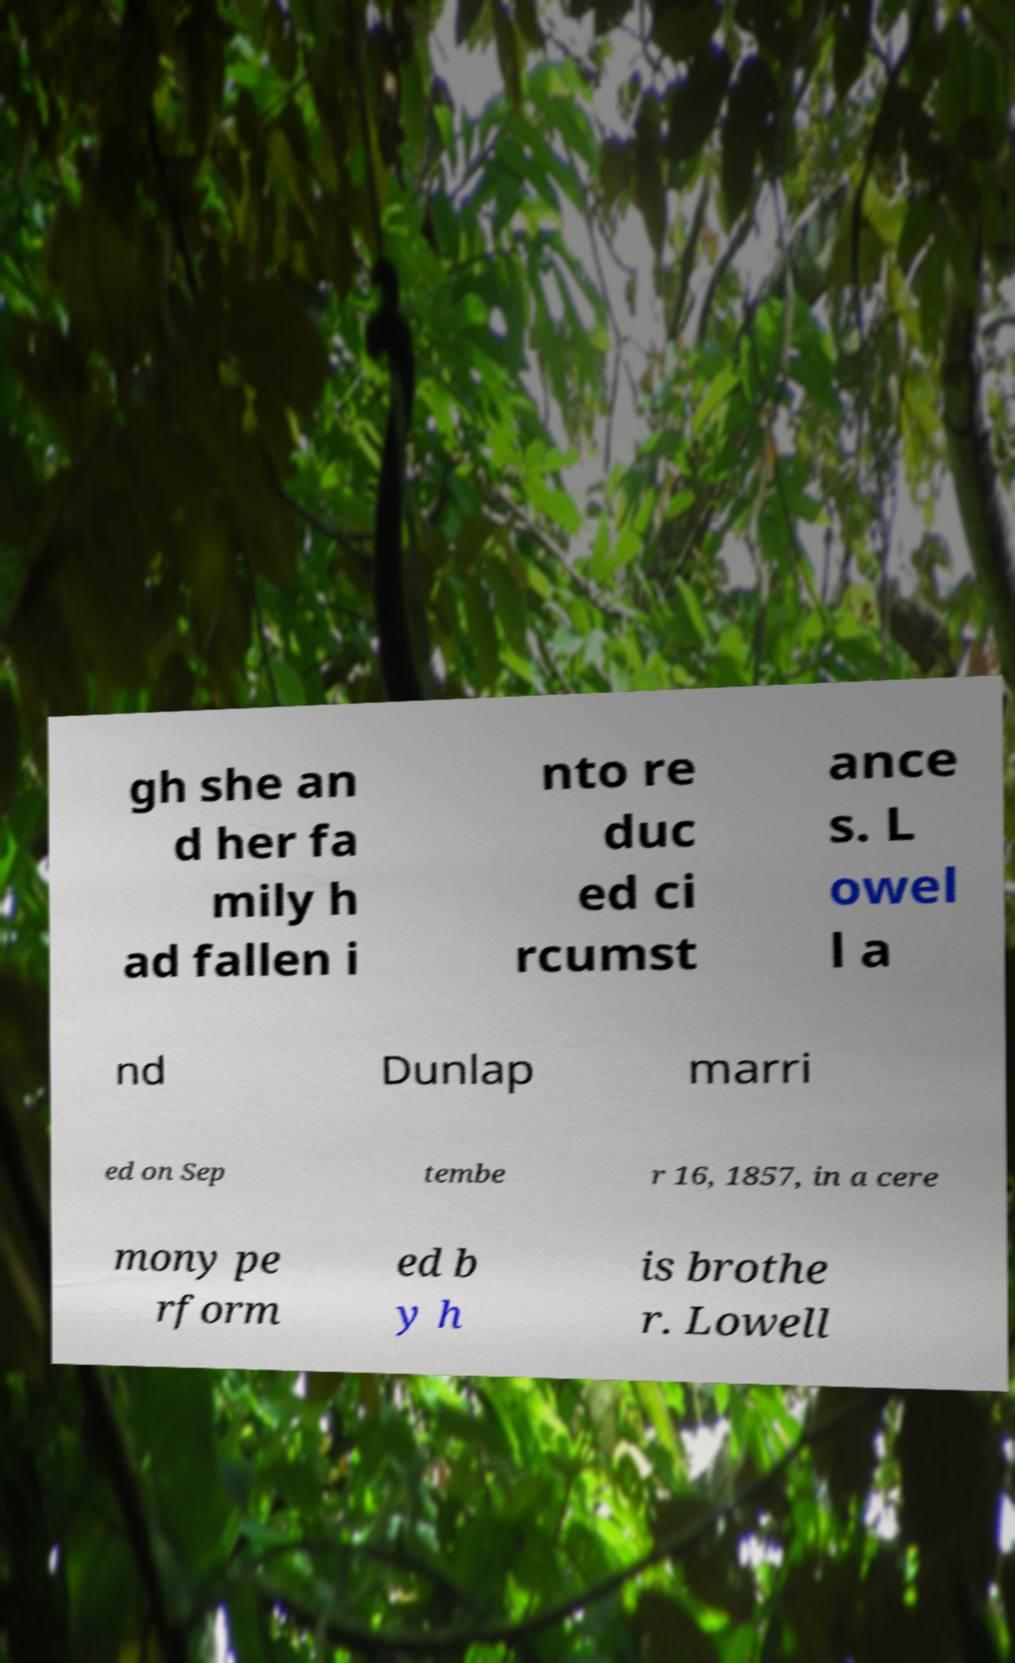Can you read and provide the text displayed in the image?This photo seems to have some interesting text. Can you extract and type it out for me? gh she an d her fa mily h ad fallen i nto re duc ed ci rcumst ance s. L owel l a nd Dunlap marri ed on Sep tembe r 16, 1857, in a cere mony pe rform ed b y h is brothe r. Lowell 